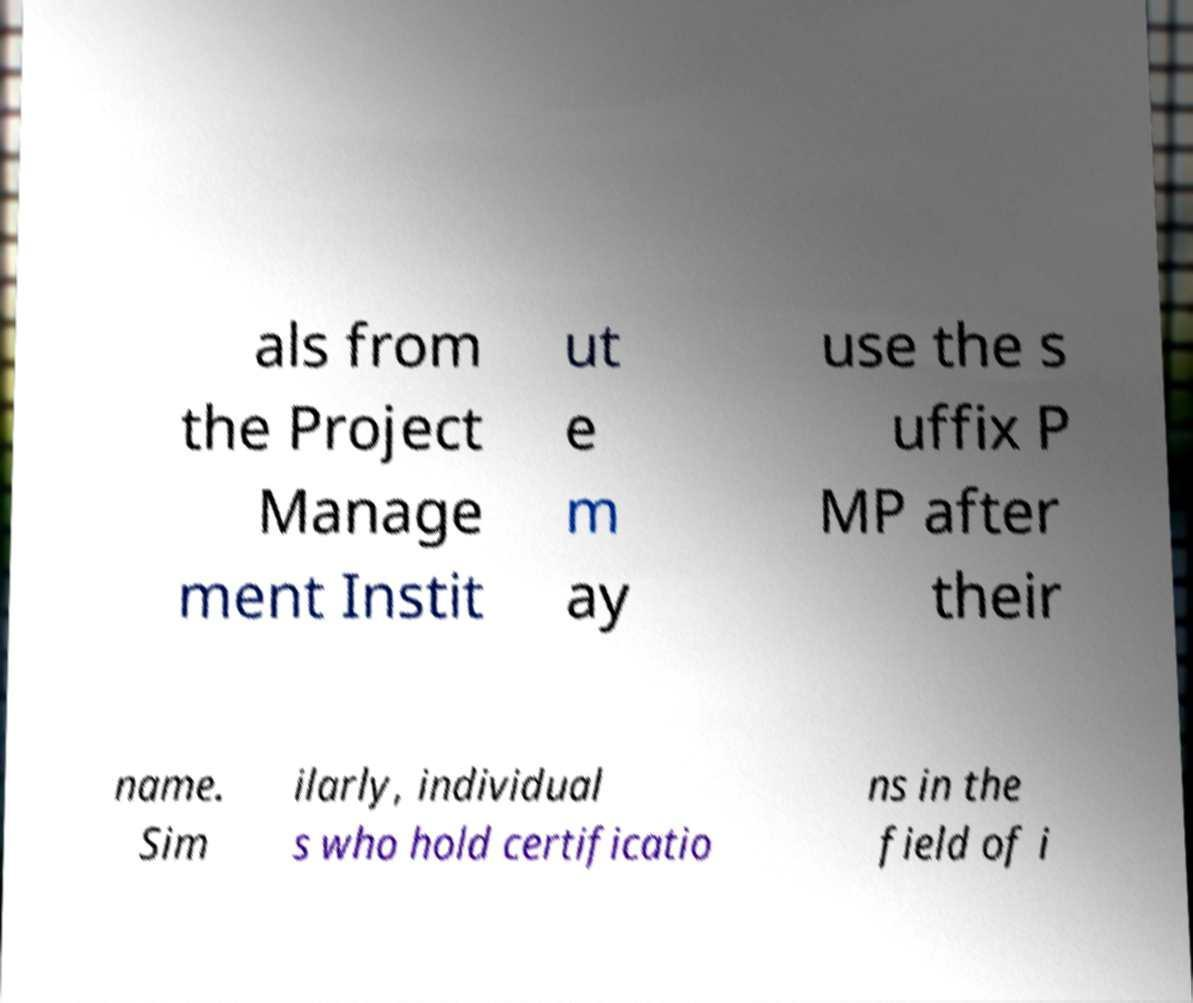For documentation purposes, I need the text within this image transcribed. Could you provide that? als from the Project Manage ment Instit ut e m ay use the s uffix P MP after their name. Sim ilarly, individual s who hold certificatio ns in the field of i 